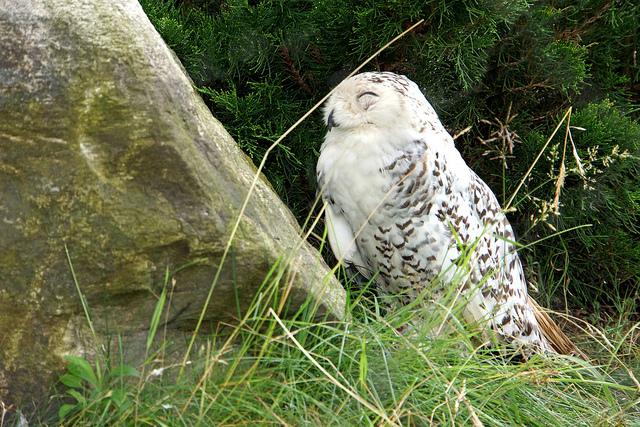Is this bir asleep?
Answer briefly. Yes. What type of bird is this?
Quick response, please. Owl. What does this bird eat?
Quick response, please. Mice. 